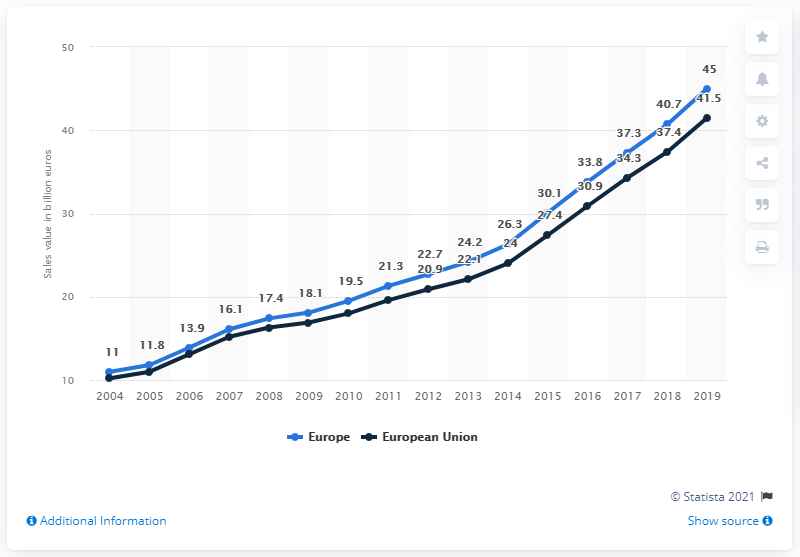Mention a couple of crucial points in this snapshot. In 2019, the retail sales of organic food in Germany amounted to approximately 45 billion Euros. According to data released in 2019, organic retail sales in Europe reached a total of 45 billion euros. In 2019, the organic retail sales in the European Union were valued at approximately 41.5 billion euros. 